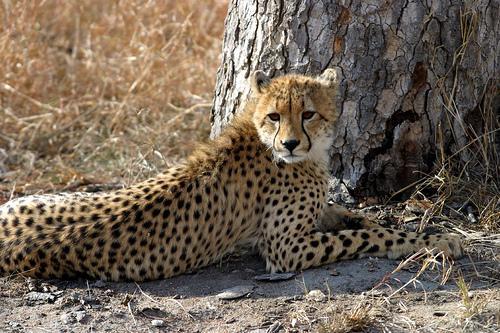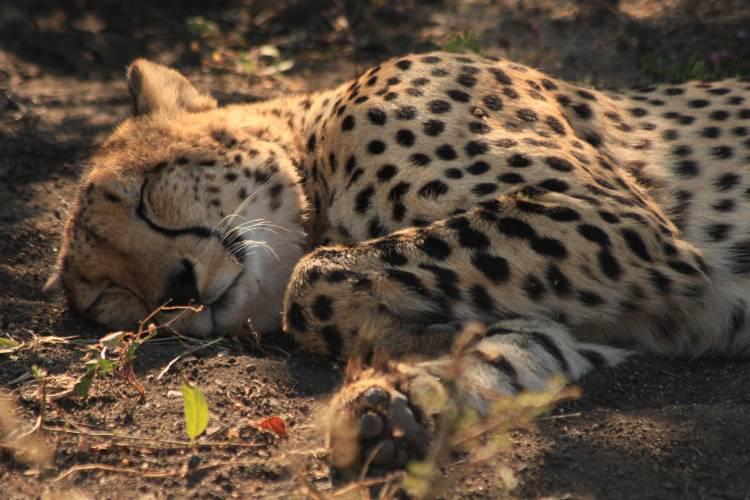The first image is the image on the left, the second image is the image on the right. Assess this claim about the two images: "A larger spotted wild cat is extending its neck and head toward the head of a smaller spotted wild cat.". Correct or not? Answer yes or no. No. The first image is the image on the left, the second image is the image on the right. Analyze the images presented: Is the assertion "The right image has at least two cheetahs." valid? Answer yes or no. No. 